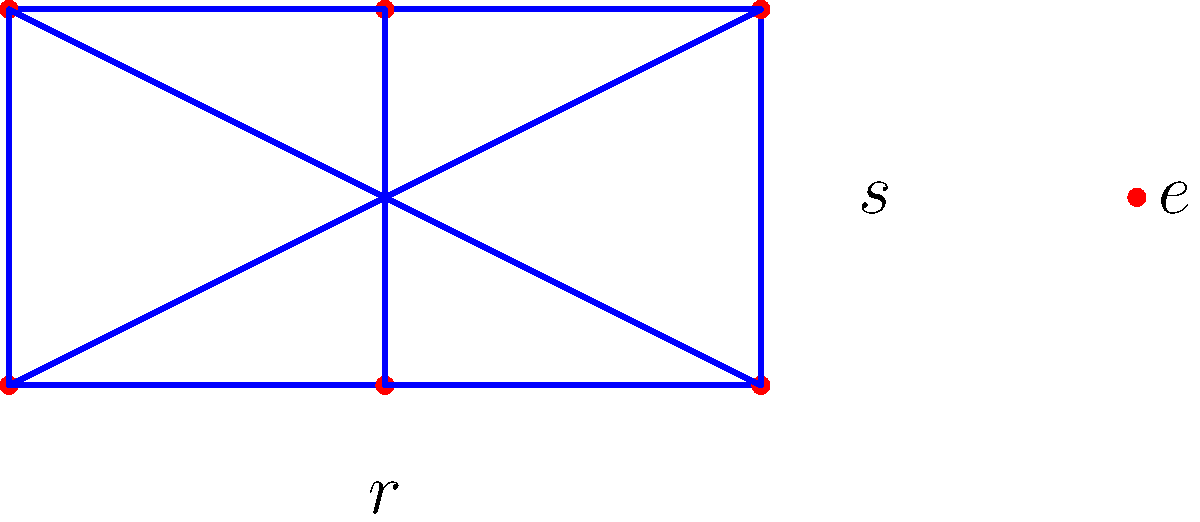In the context of group theory, examine the Cayley diagram of the dihedral group $D_6$ for a regular hexagon shown above. How would you identify and characterize the subgroup generated by the rotation $r^2$? To identify and characterize the subgroup generated by $r^2$ in the dihedral group $D_6$, we can follow these steps:

1. Recall that in $D_6$, $r$ represents a rotation by 60° (one-sixth of a full rotation), and $s$ represents a reflection.

2. The element $r^2$ represents a rotation by 120° (one-third of a full rotation).

3. To generate the subgroup, we need to apply $r^2$ repeatedly:
   - $(r^2)^1 = r^2$ (120° rotation)
   - $(r^2)^2 = r^4$ (240° rotation)
   - $(r^2)^3 = r^6 = e$ (360° rotation, identity)

4. This subgroup consists of {$e, r^2, r^4$}, which are rotations by 0°, 120°, and 240°.

5. In the Cayley diagram, these elements form a cycle of length 3.

6. This subgroup is isomorphic to the cyclic group $C_3$.

7. It's a normal subgroup of $D_6$ because rotations commute with all elements of $D_6$.

8. The order of this subgroup is 3, which divides the order of $D_6$ (which is 12), as expected from Lagrange's theorem.
Answer: Cyclic subgroup of order 3, $\{e, r^2, r^4\}$, isomorphic to $C_3$ 